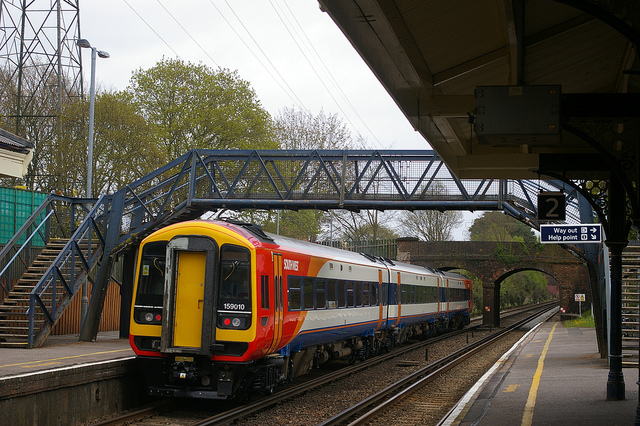Read and extract the text from this image. 2 Way Don't 159010 